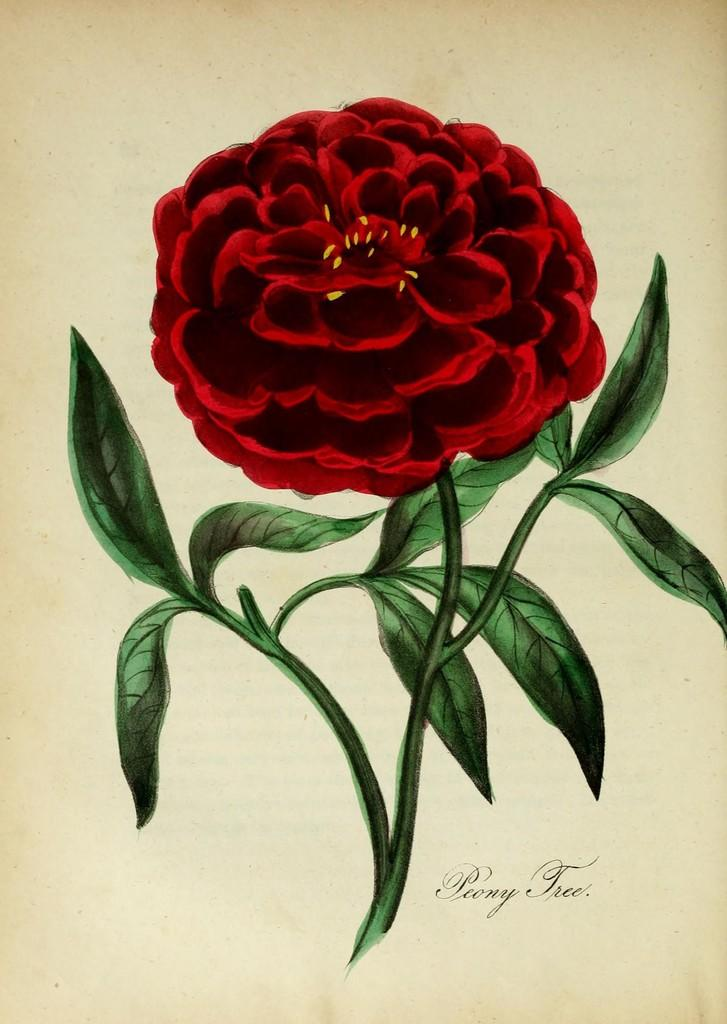What type of flower is depicted in the painting? There is a red rose in the painting. Can you identify the artist of the painting? The person's name is visible in the bottom right corner of the image. What type of space exploration is depicted in the painting? There is no depiction of space exploration in the painting; it features a red rose. What type of beast can be seen in the painting? There are no beasts present in the painting; it features a red rose. 